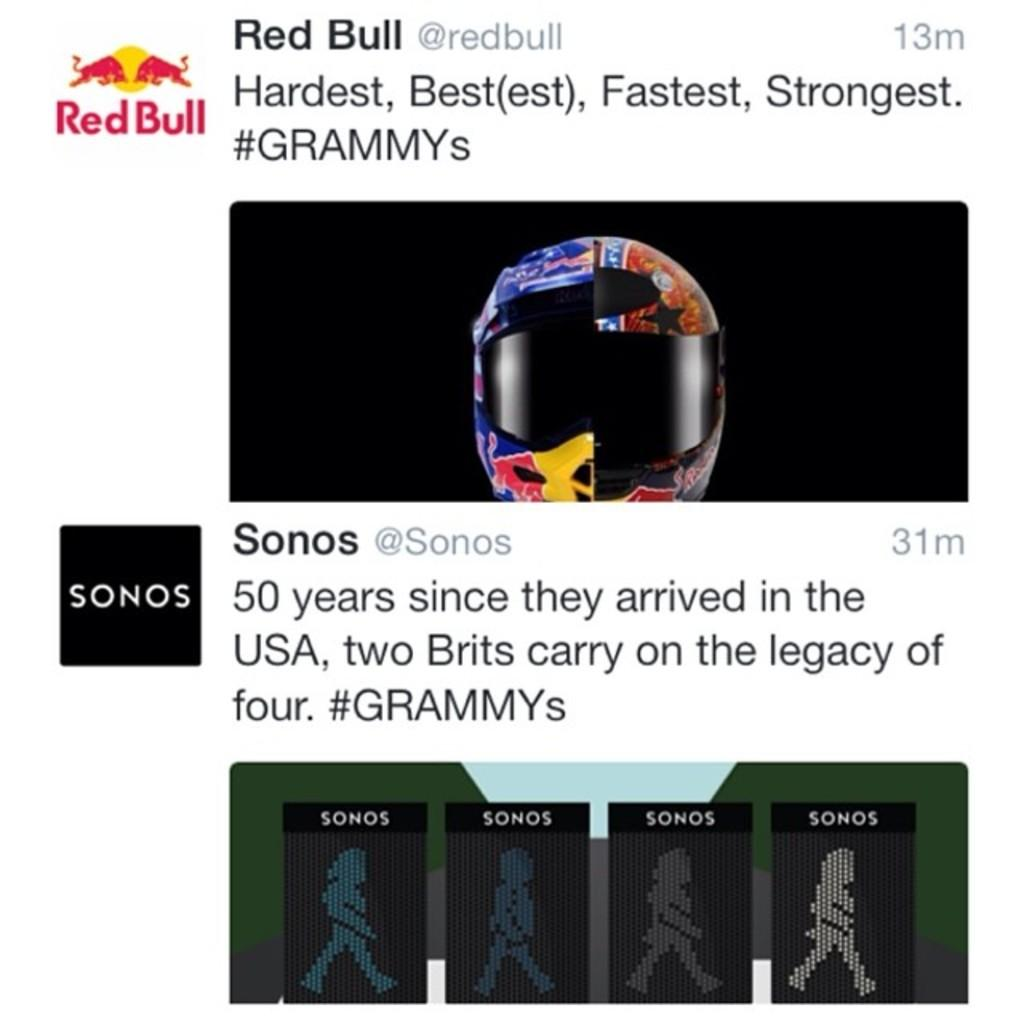What type of content is displayed in the image? The image contains a screenshot. What can be read or seen in the screenshot? There is text visible in the image, and there are images present as well. What type of symbols or graphics can be seen in the screenshot? There are icons present in the image. Can you describe any specific object visible in the image? A colorful helmet is visible in the image. How much wealth is represented by the pail in the image? There is no pail present in the image, so it is not possible to determine the amount of wealth represented. 